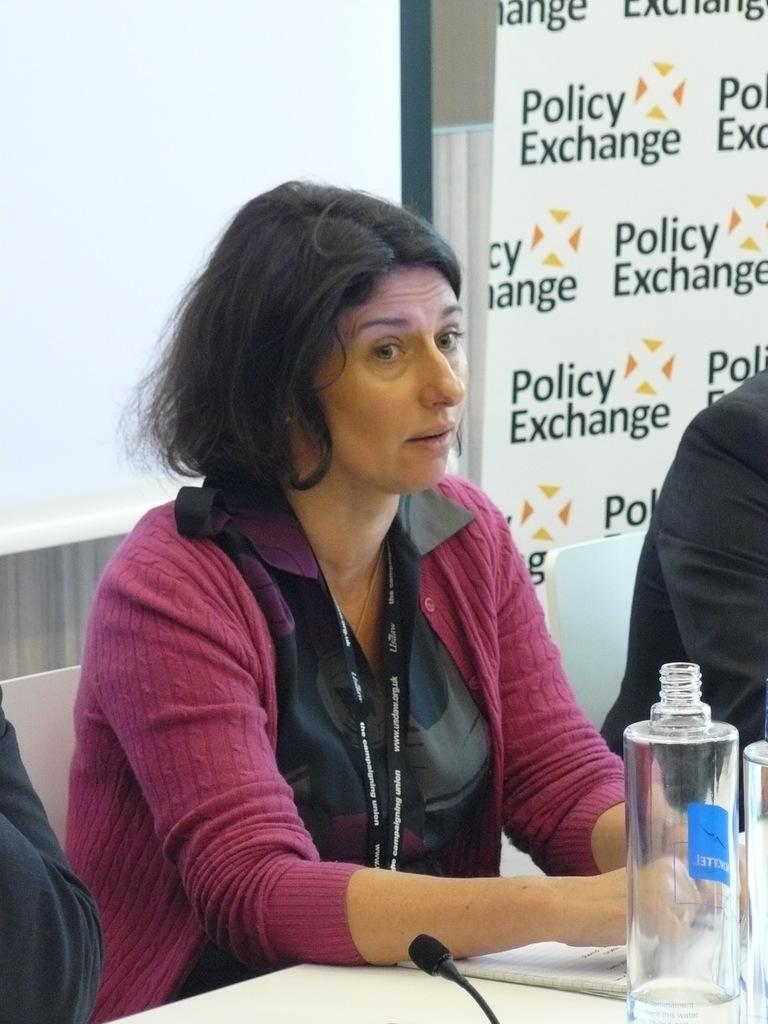<image>
Give a short and clear explanation of the subsequent image. Women speaking in front of a board that says "Policy Exchange". 